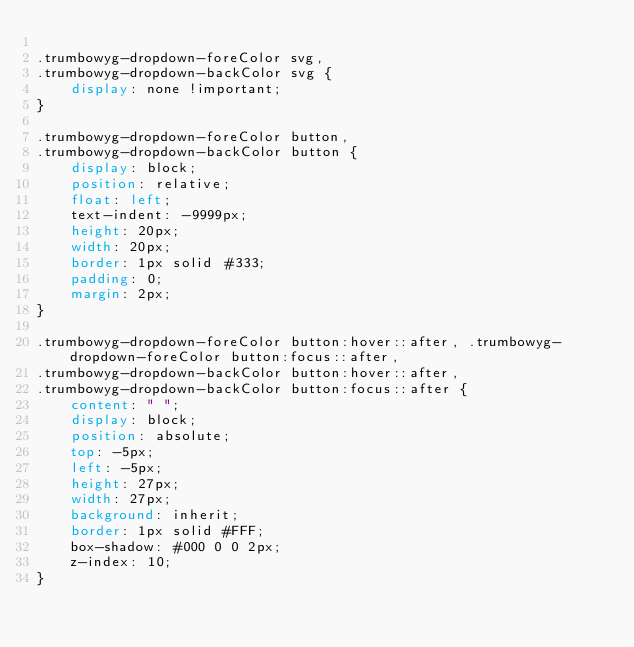<code> <loc_0><loc_0><loc_500><loc_500><_CSS_>
.trumbowyg-dropdown-foreColor svg,
.trumbowyg-dropdown-backColor svg {
    display: none !important;
}

.trumbowyg-dropdown-foreColor button,
.trumbowyg-dropdown-backColor button {
    display: block;
    position: relative;
    float: left;
    text-indent: -9999px;
    height: 20px;
    width: 20px;
    border: 1px solid #333;
    padding: 0;
    margin: 2px;
}

.trumbowyg-dropdown-foreColor button:hover::after, .trumbowyg-dropdown-foreColor button:focus::after,
.trumbowyg-dropdown-backColor button:hover::after,
.trumbowyg-dropdown-backColor button:focus::after {
    content: " ";
    display: block;
    position: absolute;
    top: -5px;
    left: -5px;
    height: 27px;
    width: 27px;
    background: inherit;
    border: 1px solid #FFF;
    box-shadow: #000 0 0 2px;
    z-index: 10;
}
</code> 